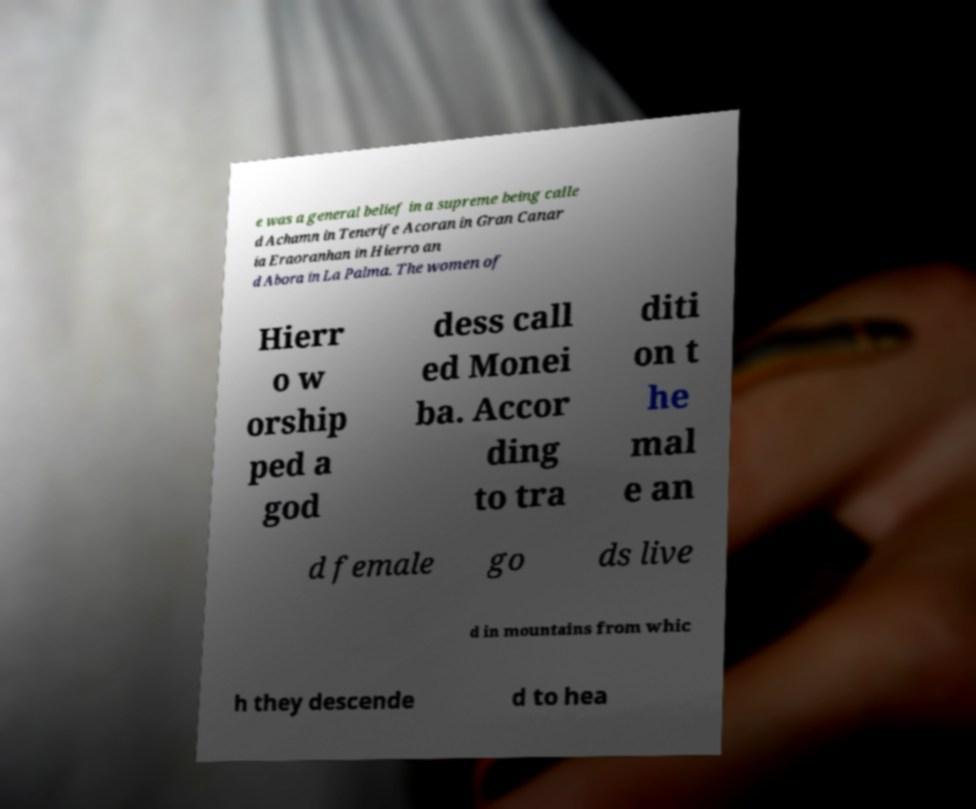For documentation purposes, I need the text within this image transcribed. Could you provide that? e was a general belief in a supreme being calle d Achamn in Tenerife Acoran in Gran Canar ia Eraoranhan in Hierro an d Abora in La Palma. The women of Hierr o w orship ped a god dess call ed Monei ba. Accor ding to tra diti on t he mal e an d female go ds live d in mountains from whic h they descende d to hea 